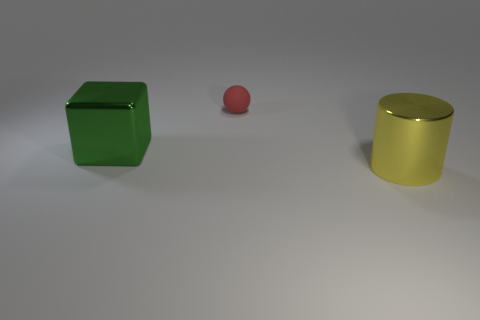There is a shiny object that is on the right side of the green shiny object; what color is it? The shiny object on the right side of the green cube is colored pink, exhibiting a soft hue and a glossy finish. 